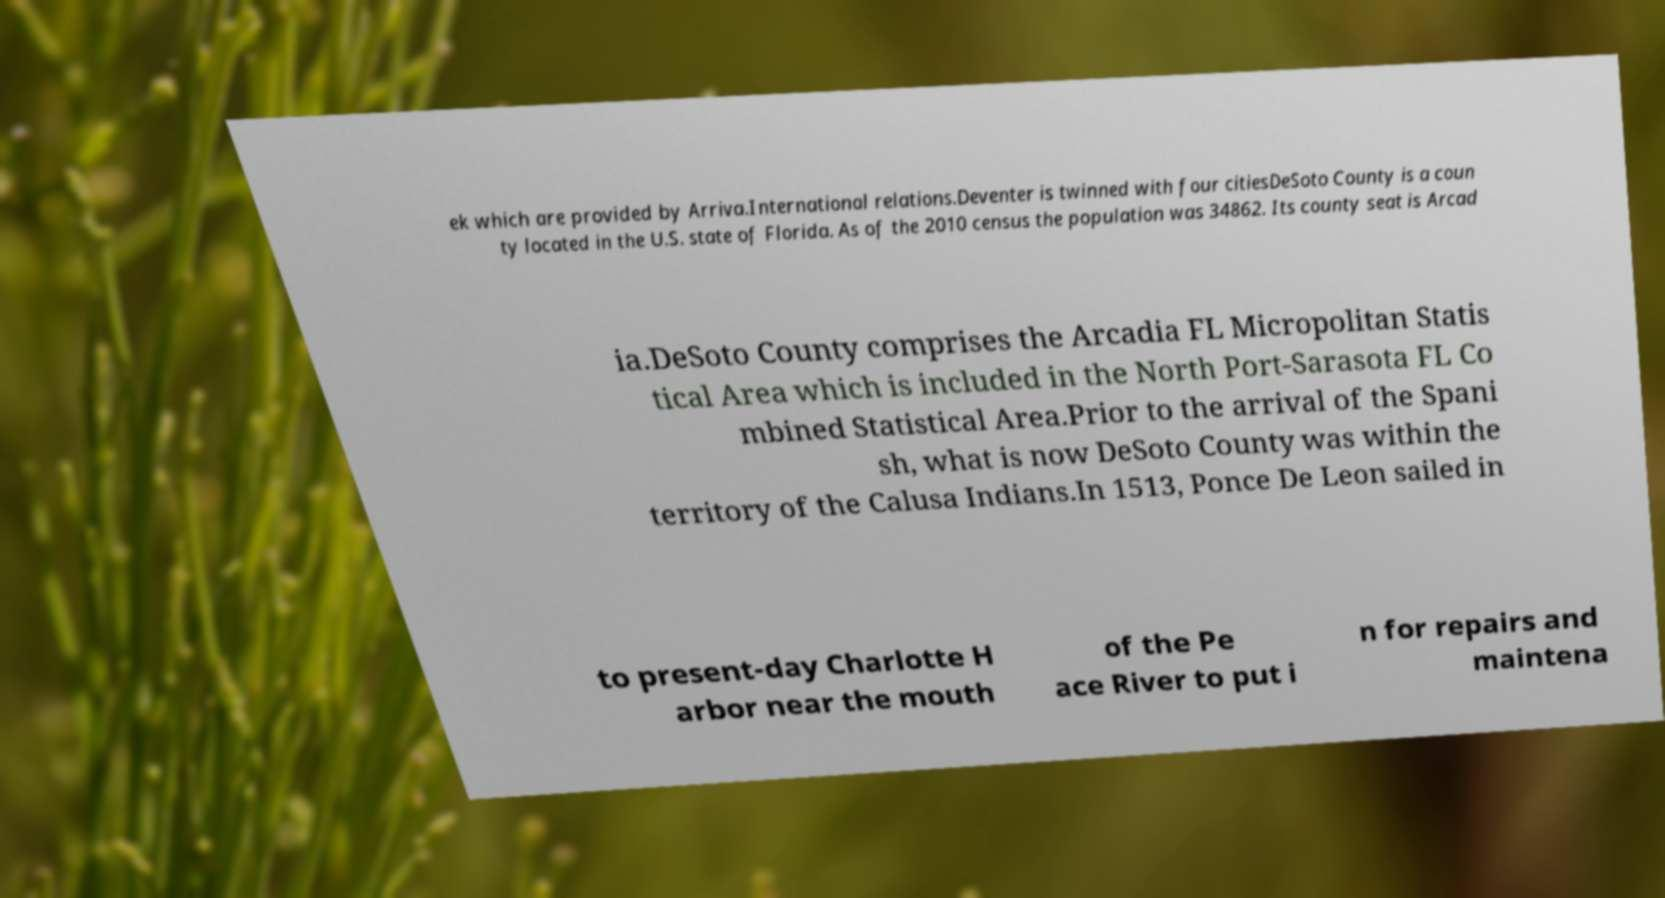Please read and relay the text visible in this image. What does it say? ek which are provided by Arriva.International relations.Deventer is twinned with four citiesDeSoto County is a coun ty located in the U.S. state of Florida. As of the 2010 census the population was 34862. Its county seat is Arcad ia.DeSoto County comprises the Arcadia FL Micropolitan Statis tical Area which is included in the North Port-Sarasota FL Co mbined Statistical Area.Prior to the arrival of the Spani sh, what is now DeSoto County was within the territory of the Calusa Indians.In 1513, Ponce De Leon sailed in to present-day Charlotte H arbor near the mouth of the Pe ace River to put i n for repairs and maintena 